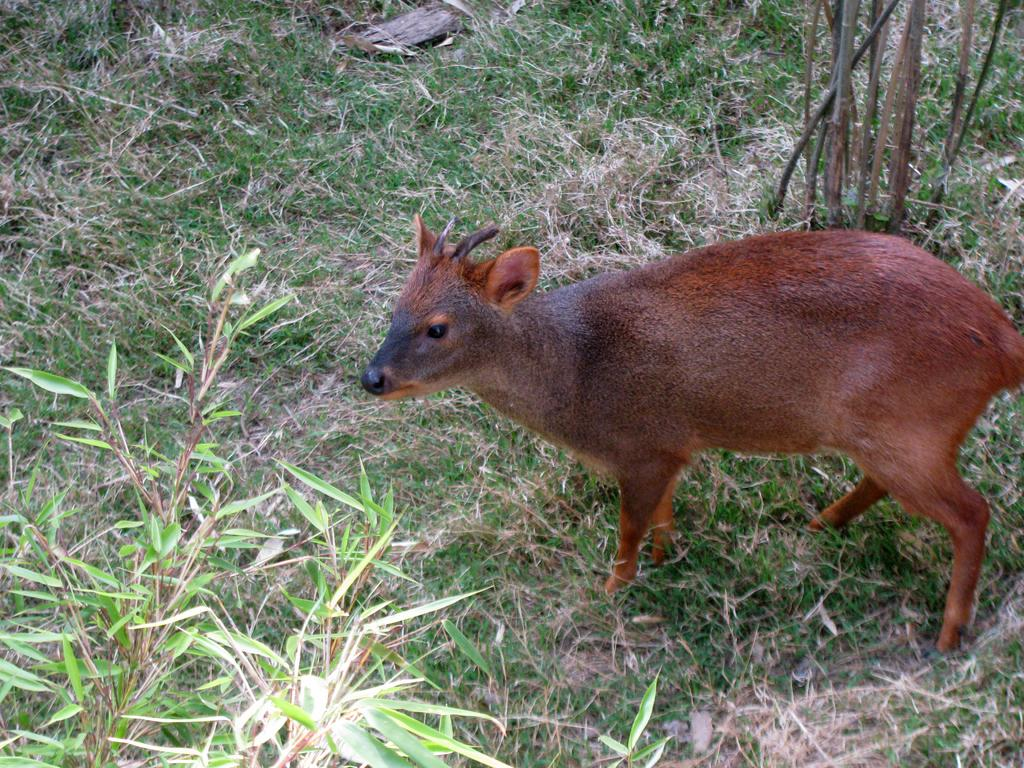What type of animal is in the image? There is a baby deer in the image. What is the baby deer standing on? The baby deer is standing on grass. Are there any plants visible in the image? Yes, there are a few plants around the baby deer. What type of snail can be seen crawling on the bottle in the image? There is no snail or bottle present in the image; it features a baby deer standing on grass with a few plants around it. 